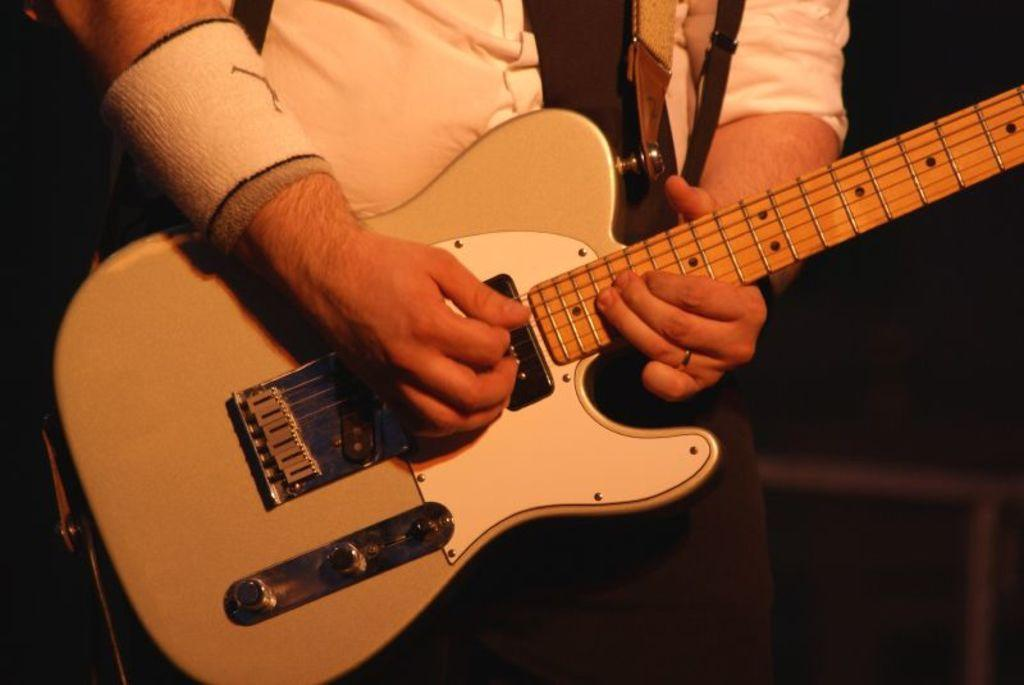Who is the main subject in the image? There is a man in the image. What is the man wearing? The man is wearing a white shirt. What object is the man holding? The man is holding a guitar. What is the man doing with the guitar? The man is playing the guitar. How many tables are visible in the image? There are no tables visible in the image; it features a man playing a guitar. What type of baseball equipment can be seen in the image? There is no baseball equipment present in the image. 